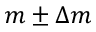Convert formula to latex. <formula><loc_0><loc_0><loc_500><loc_500>m \pm \Delta m</formula> 